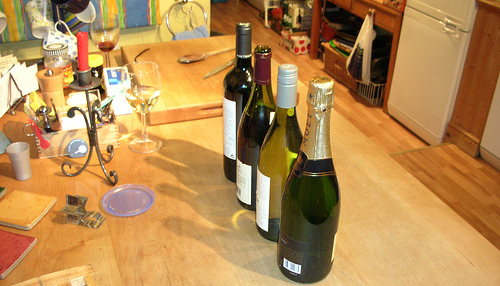<image>
Can you confirm if the glass is behind the candle? Yes. From this viewpoint, the glass is positioned behind the candle, with the candle partially or fully occluding the glass. Where is the beer bottles in relation to the table? Is it on the table? Yes. Looking at the image, I can see the beer bottles is positioned on top of the table, with the table providing support. 